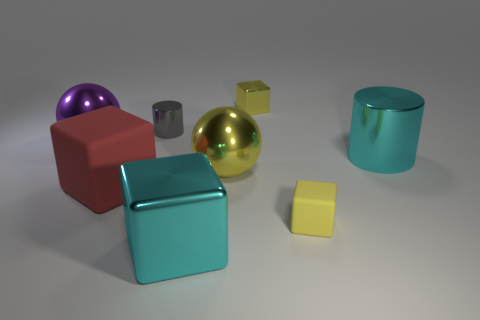There is a yellow metallic thing that is the same size as the red matte cube; what is its shape?
Make the answer very short. Sphere. Is the tiny yellow matte thing the same shape as the large red matte thing?
Provide a succinct answer. Yes. How many other yellow metal things are the same shape as the big yellow object?
Your response must be concise. 0. There is a tiny gray object; what number of big cyan blocks are behind it?
Your answer should be compact. 0. Is the color of the tiny thing that is in front of the yellow metal sphere the same as the tiny shiny block?
Offer a terse response. Yes. What number of yellow balls have the same size as the cyan block?
Provide a short and direct response. 1. What is the shape of the purple thing that is made of the same material as the big cyan block?
Give a very brief answer. Sphere. Are there any other cubes of the same color as the tiny shiny block?
Give a very brief answer. Yes. What is the material of the large red block?
Offer a very short reply. Rubber. What number of things are either purple shiny balls or big blue metal blocks?
Offer a terse response. 1. 